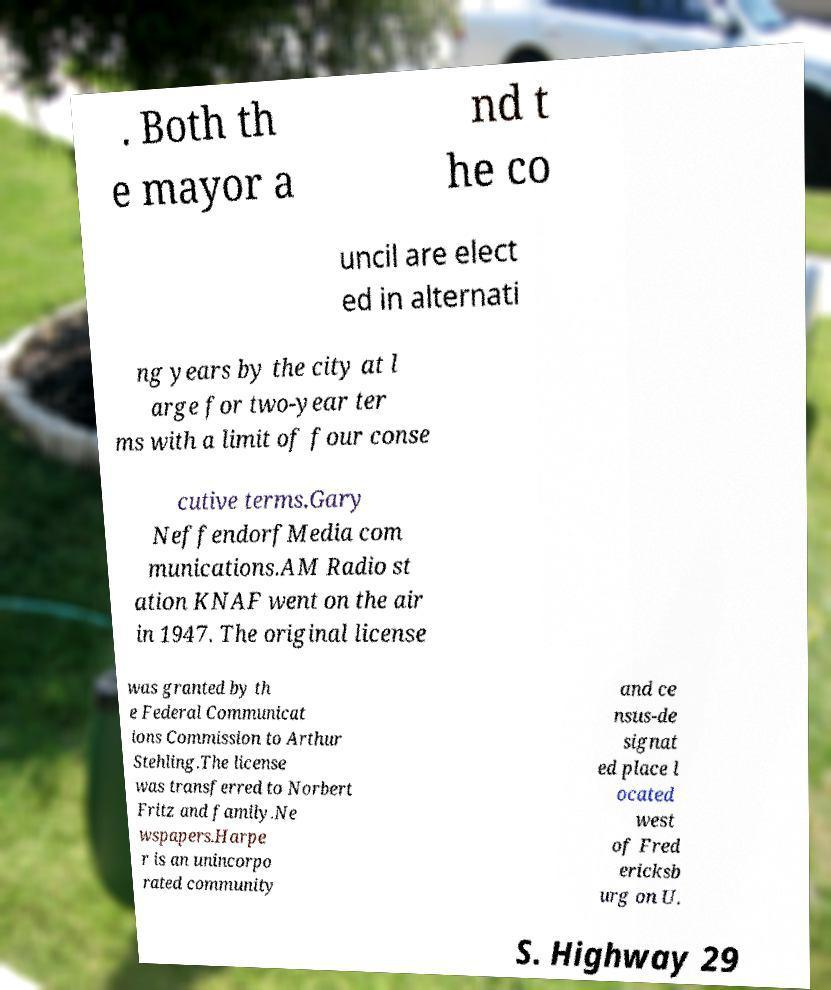Could you extract and type out the text from this image? . Both th e mayor a nd t he co uncil are elect ed in alternati ng years by the city at l arge for two-year ter ms with a limit of four conse cutive terms.Gary NeffendorfMedia com munications.AM Radio st ation KNAF went on the air in 1947. The original license was granted by th e Federal Communicat ions Commission to Arthur Stehling.The license was transferred to Norbert Fritz and family.Ne wspapers.Harpe r is an unincorpo rated community and ce nsus-de signat ed place l ocated west of Fred ericksb urg on U. S. Highway 29 